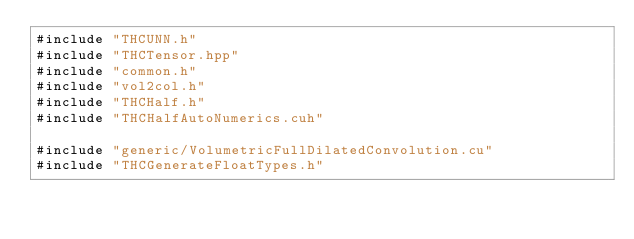<code> <loc_0><loc_0><loc_500><loc_500><_Cuda_>#include "THCUNN.h"
#include "THCTensor.hpp"
#include "common.h"
#include "vol2col.h"
#include "THCHalf.h"
#include "THCHalfAutoNumerics.cuh"

#include "generic/VolumetricFullDilatedConvolution.cu"
#include "THCGenerateFloatTypes.h"
</code> 